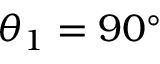<formula> <loc_0><loc_0><loc_500><loc_500>\theta _ { 1 } = 9 0 ^ { \circ }</formula> 